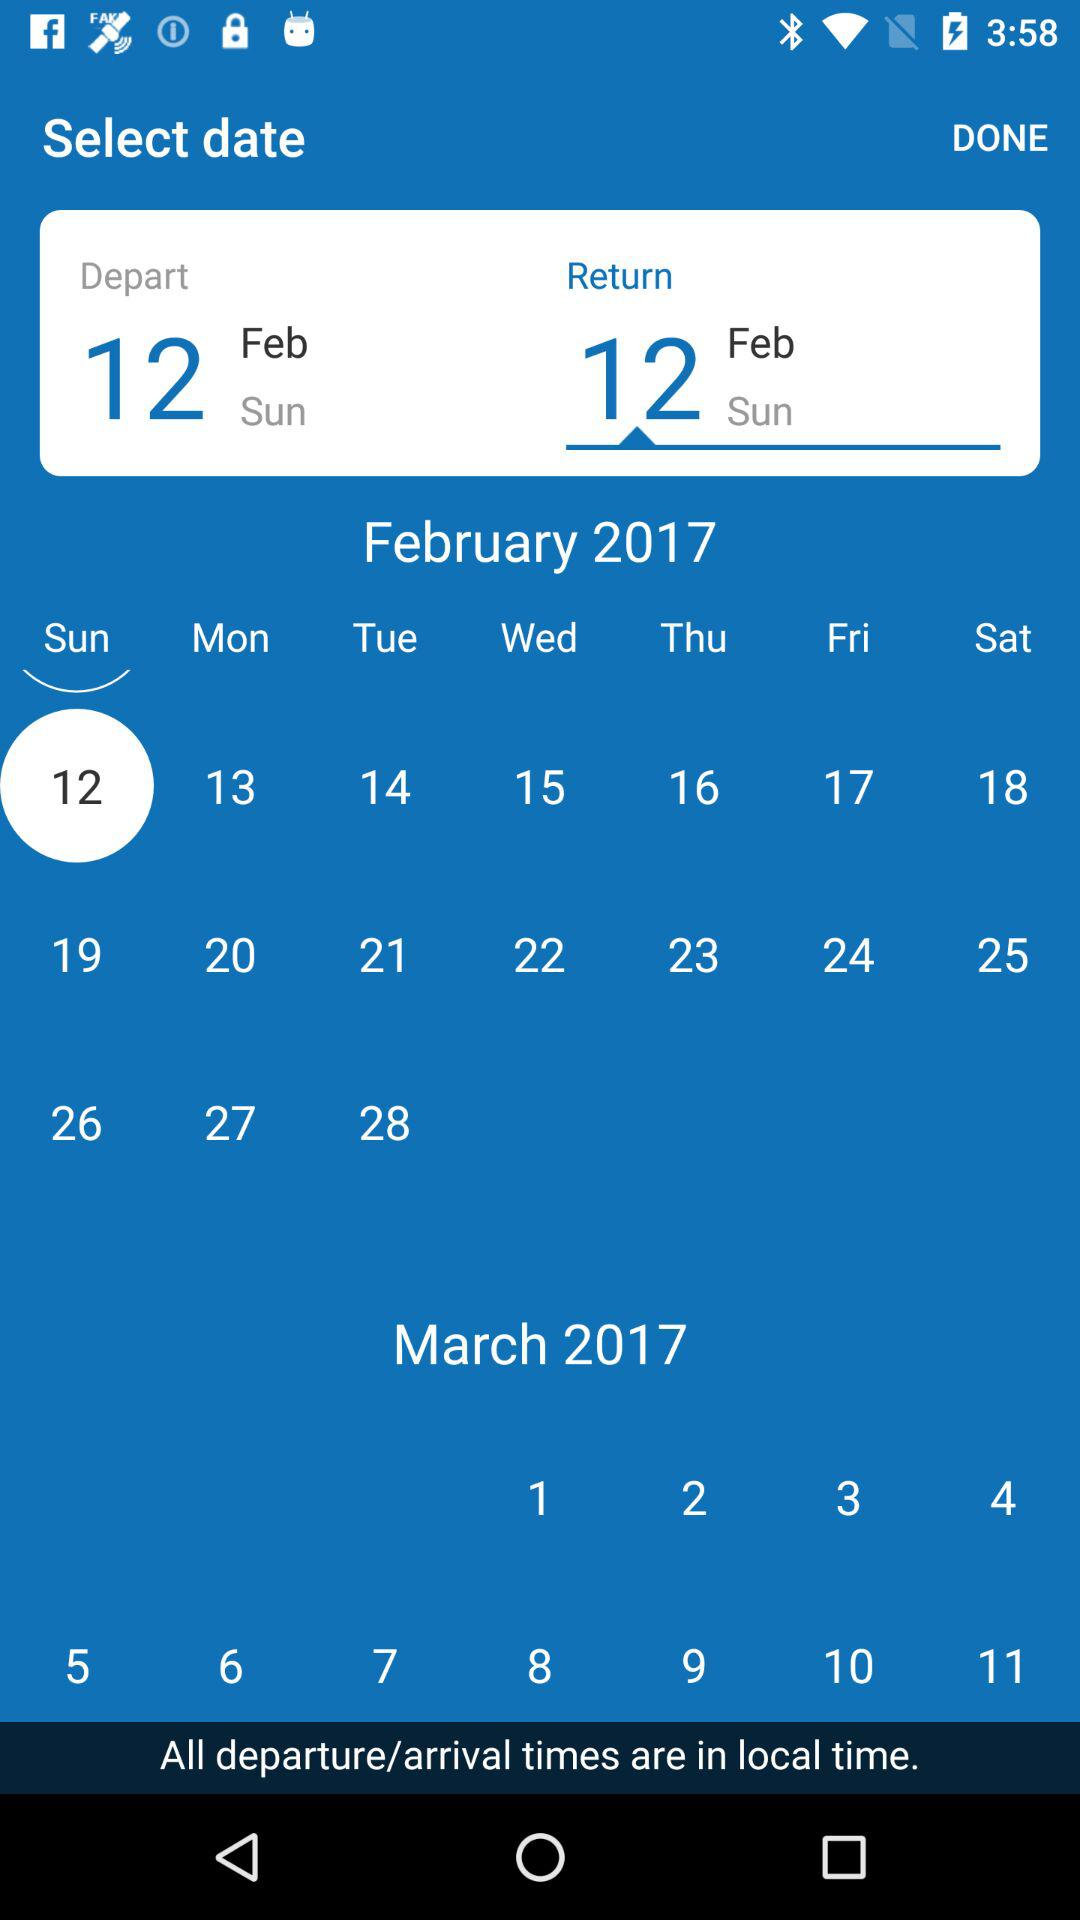Which date is selected? The selected date is Sunday, February 12, 2017. 